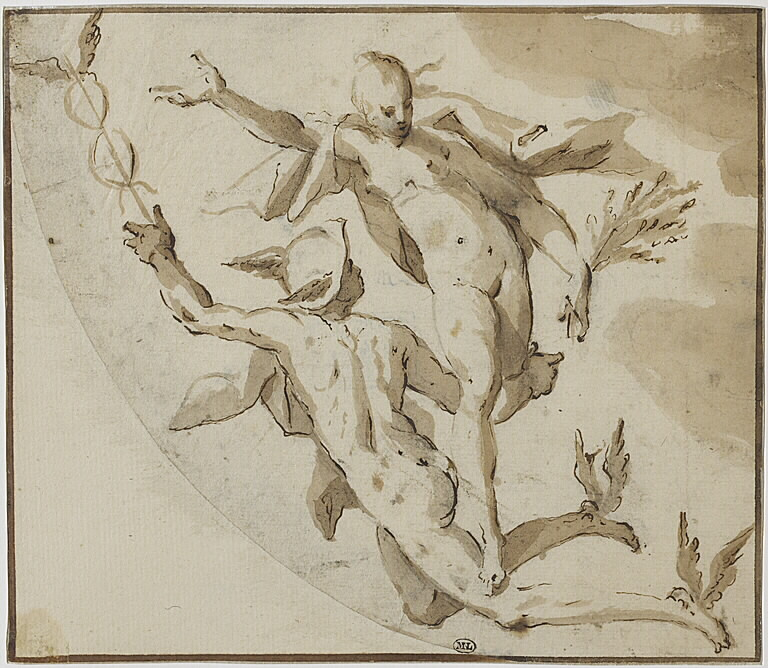If you could step into this artwork, what might you experience from the perspective of these figures? Stepping into this artwork, you might experience a thrilling sense of motion and liberation. From the perspective of the male figure, you would feel the exertion and exhilaration of lifting and supporting the female figure, your muscles straining with effort but buoyed by the lightness of the moment. As the female figure, you would experience a sense of grace and weightlessness, as if soaring through the air with effortless ease. The surrounding space would feel expansive and dynamic, filled with a swirling energy that heightens your senses and emotions. The interplay of light and shadow would create a vivid and immersive environment, making you acutely aware of every movement and gesture. 